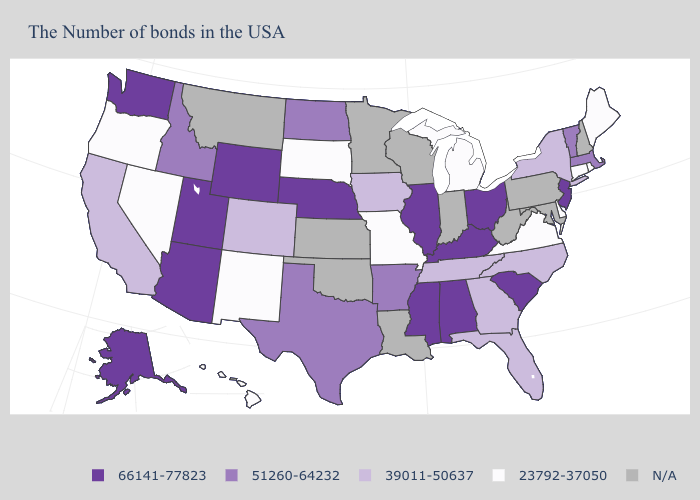How many symbols are there in the legend?
Give a very brief answer. 5. What is the value of Alabama?
Short answer required. 66141-77823. What is the value of Indiana?
Concise answer only. N/A. Name the states that have a value in the range N/A?
Give a very brief answer. New Hampshire, Maryland, Pennsylvania, West Virginia, Indiana, Wisconsin, Louisiana, Minnesota, Kansas, Oklahoma, Montana. What is the value of Washington?
Give a very brief answer. 66141-77823. Does Maine have the lowest value in the Northeast?
Be succinct. Yes. Does Hawaii have the lowest value in the West?
Give a very brief answer. Yes. What is the highest value in the USA?
Concise answer only. 66141-77823. What is the value of New York?
Be succinct. 39011-50637. Name the states that have a value in the range 23792-37050?
Quick response, please. Maine, Rhode Island, Connecticut, Delaware, Virginia, Michigan, Missouri, South Dakota, New Mexico, Nevada, Oregon, Hawaii. How many symbols are there in the legend?
Answer briefly. 5. What is the value of Virginia?
Answer briefly. 23792-37050. Among the states that border Connecticut , does Massachusetts have the highest value?
Keep it brief. Yes. What is the value of Arizona?
Short answer required. 66141-77823. 